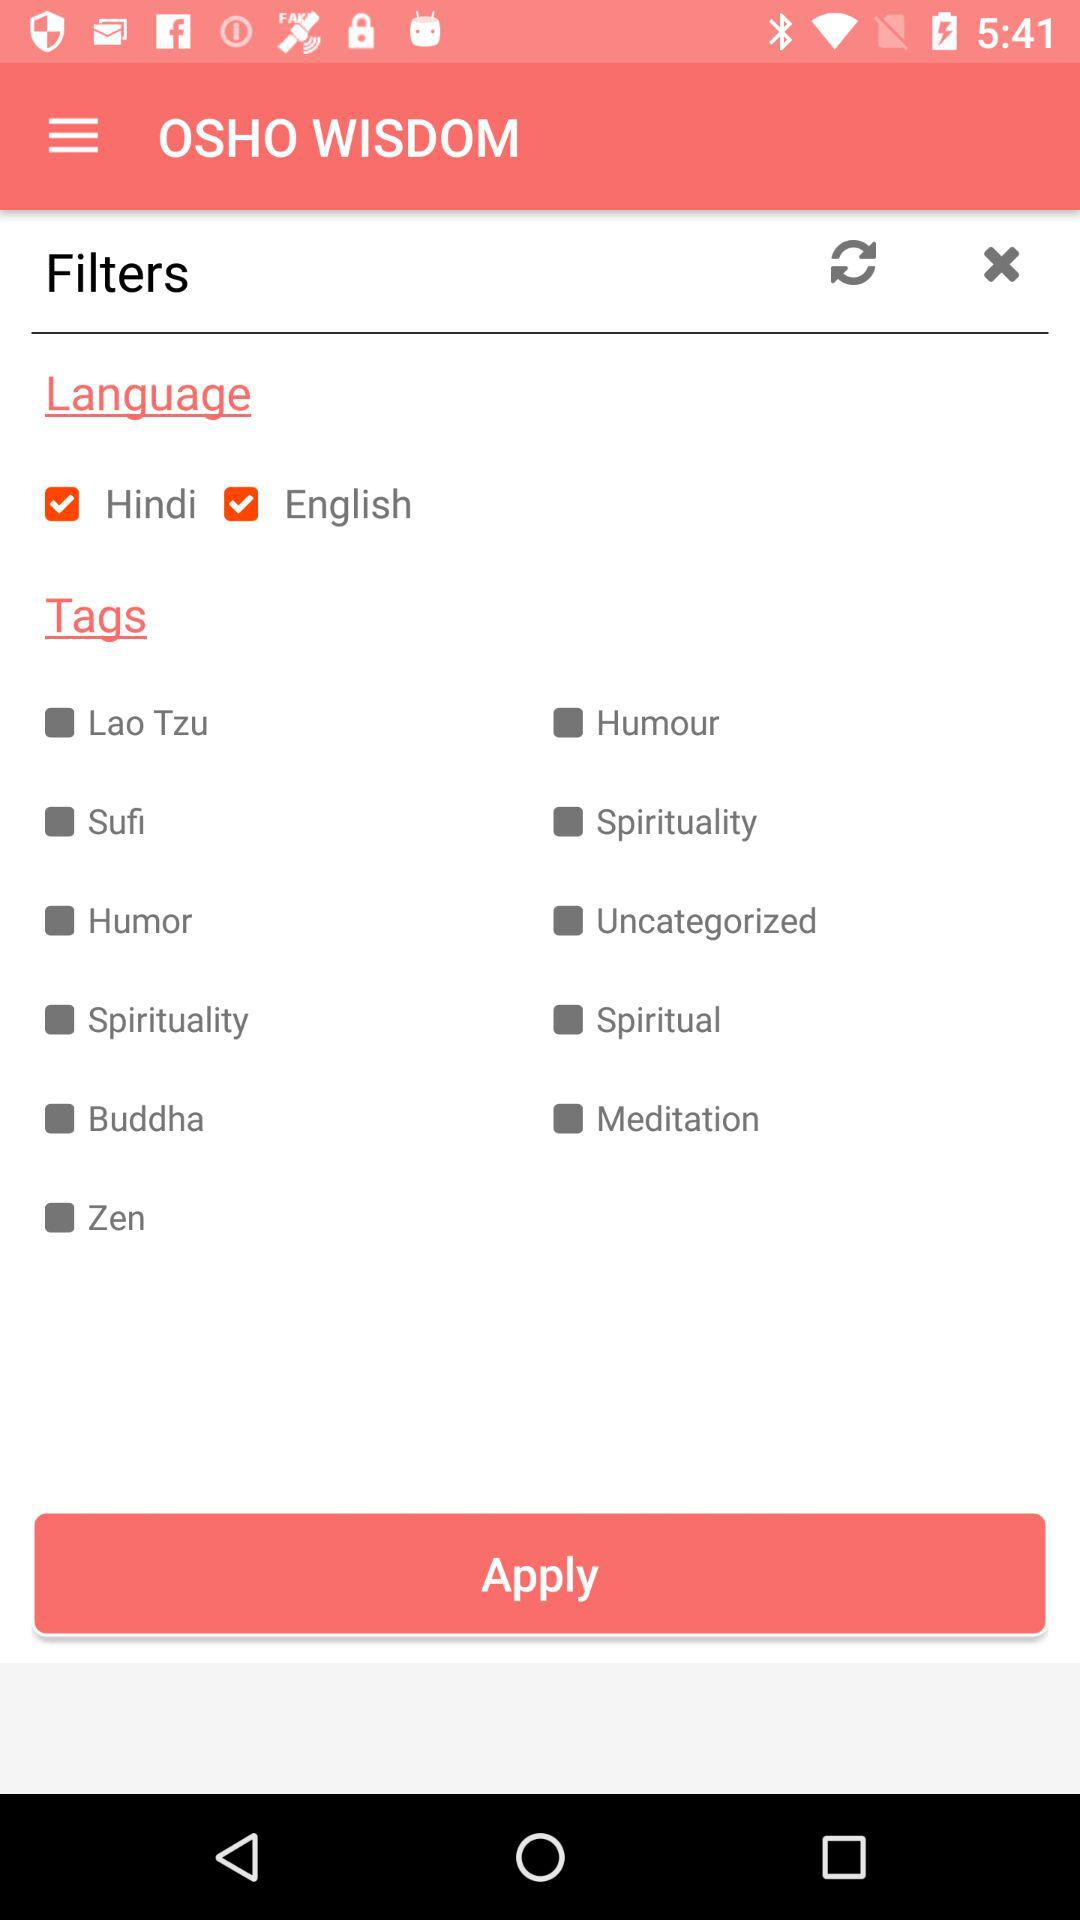Is "English" language selected or not?
Answer the question using a single word or phrase. It is selected. 